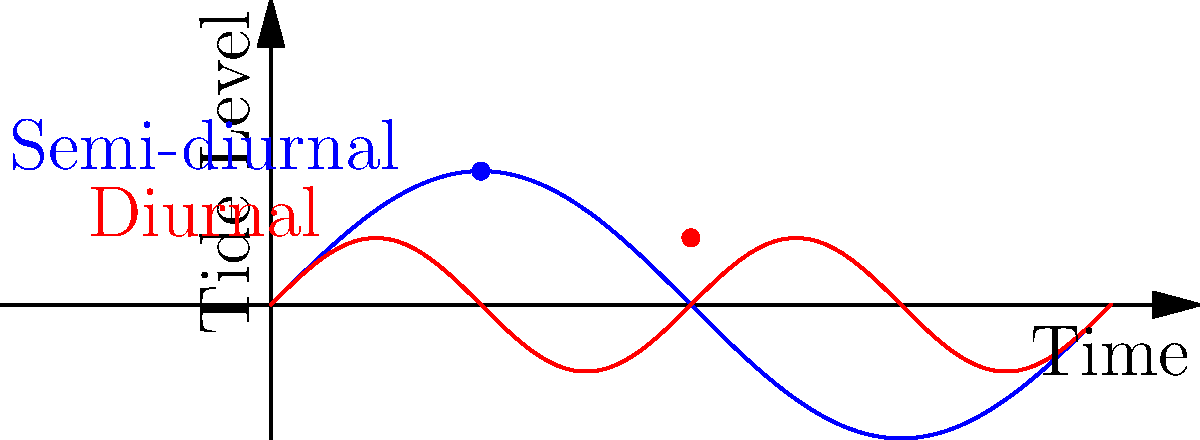Consider the tidal patterns represented in the graph, where the blue curve represents a semi-diurnal tide and the red curve represents a diurnal tide. If these tidal patterns form cyclic groups, what is the order of the group formed by the semi-diurnal tide over a 24-hour period, and how might this affect the distribution of intertidal species compared to areas with diurnal tides? To solve this problem, let's follow these steps:

1. Understand the tidal patterns:
   - Semi-diurnal tide (blue): Two high tides and two low tides per day
   - Diurnal tide (red): One high tide and one low tide per day

2. Determine the period of each tidal pattern:
   - Semi-diurnal: Completes a full cycle every 12 hours
   - Diurnal: Completes a full cycle every 24 hours

3. Calculate the order of the cyclic group for the semi-diurnal tide over 24 hours:
   - Order = Number of complete cycles in 24 hours
   - Order = 24 hours ÷ 12 hours per cycle = 2

4. Consider the effects on intertidal species distribution:
   - Semi-diurnal tides create more frequent changes in water level
   - This results in:
     a) Shorter exposure times to air for intertidal organisms
     b) More frequent submersion and emergence cycles
     c) Potentially wider vertical distribution of species in the intertidal zone

5. Compare to areas with diurnal tides:
   - Diurnal tides have longer periods of exposure and submersion
   - This may lead to:
     a) More distinct zonation patterns
     b) Species adapted to longer air exposure times in upper intertidal areas
     c) Potentially narrower vertical distribution of species

The order of the cyclic group formed by the semi-diurnal tide over a 24-hour period is 2, which means more frequent tidal changes compared to diurnal tides. This higher frequency of tidal changes in semi-diurnal areas likely results in a wider vertical distribution of intertidal species due to more frequent submersion and emergence cycles.
Answer: Order: 2; Wider vertical distribution of intertidal species 